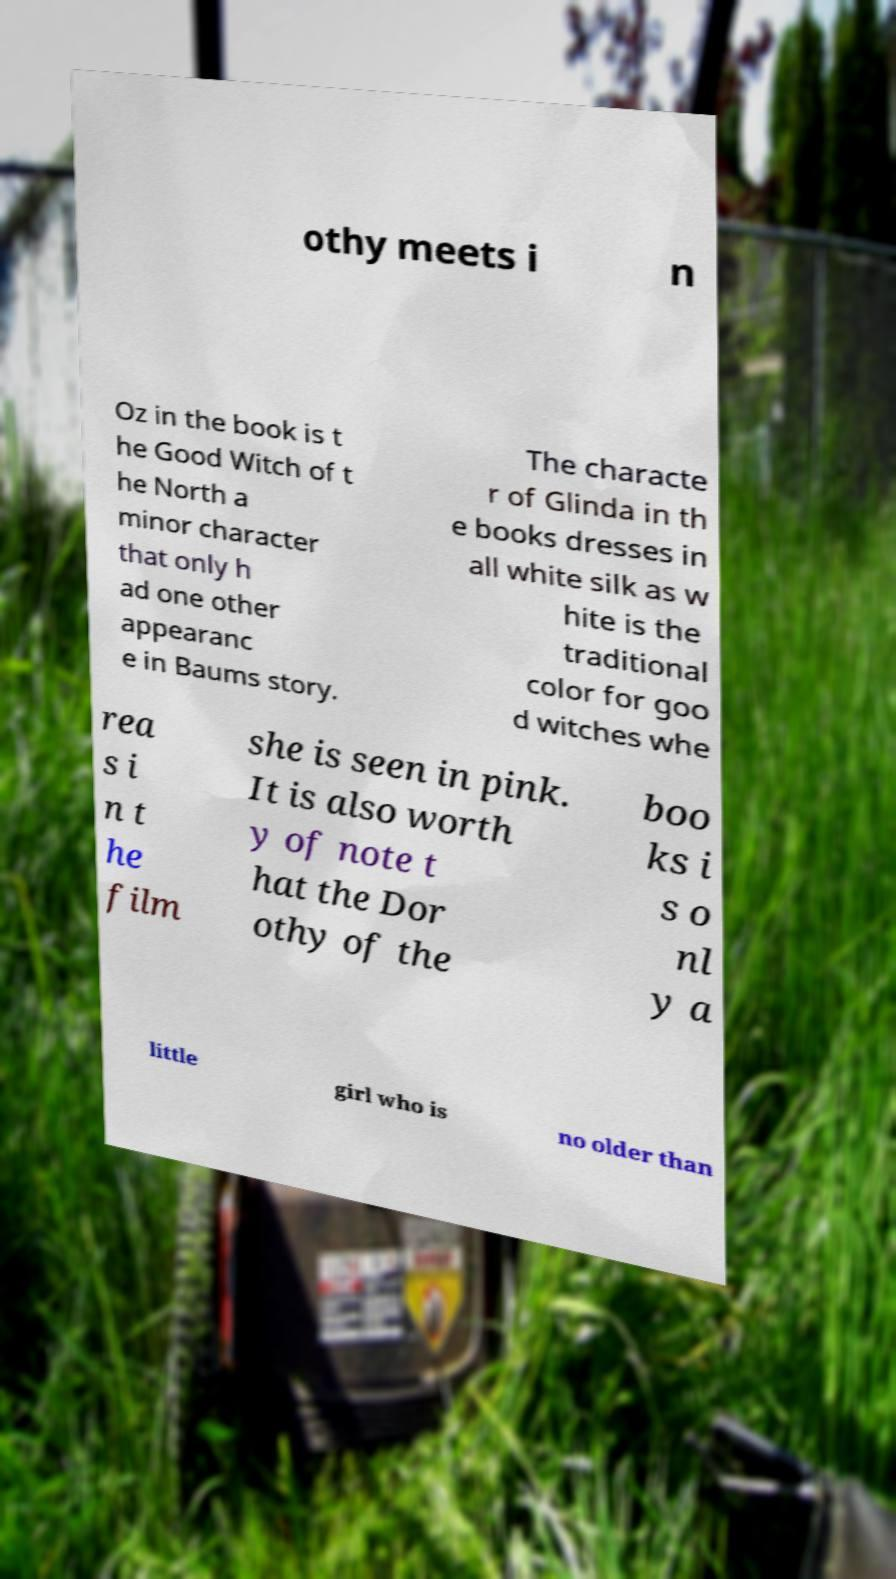Please read and relay the text visible in this image. What does it say? othy meets i n Oz in the book is t he Good Witch of t he North a minor character that only h ad one other appearanc e in Baums story. The characte r of Glinda in th e books dresses in all white silk as w hite is the traditional color for goo d witches whe rea s i n t he film she is seen in pink. It is also worth y of note t hat the Dor othy of the boo ks i s o nl y a little girl who is no older than 